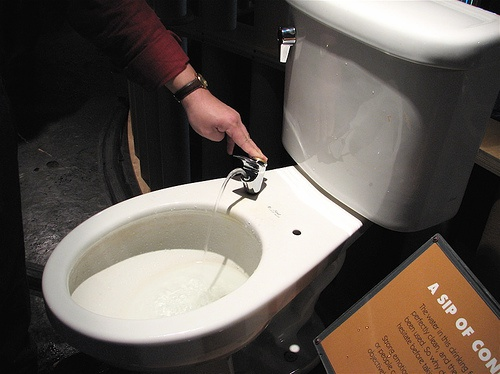Describe the objects in this image and their specific colors. I can see toilet in black, ivory, darkgray, and gray tones, people in black, maroon, brown, and salmon tones, and clock in black, maroon, and gray tones in this image. 